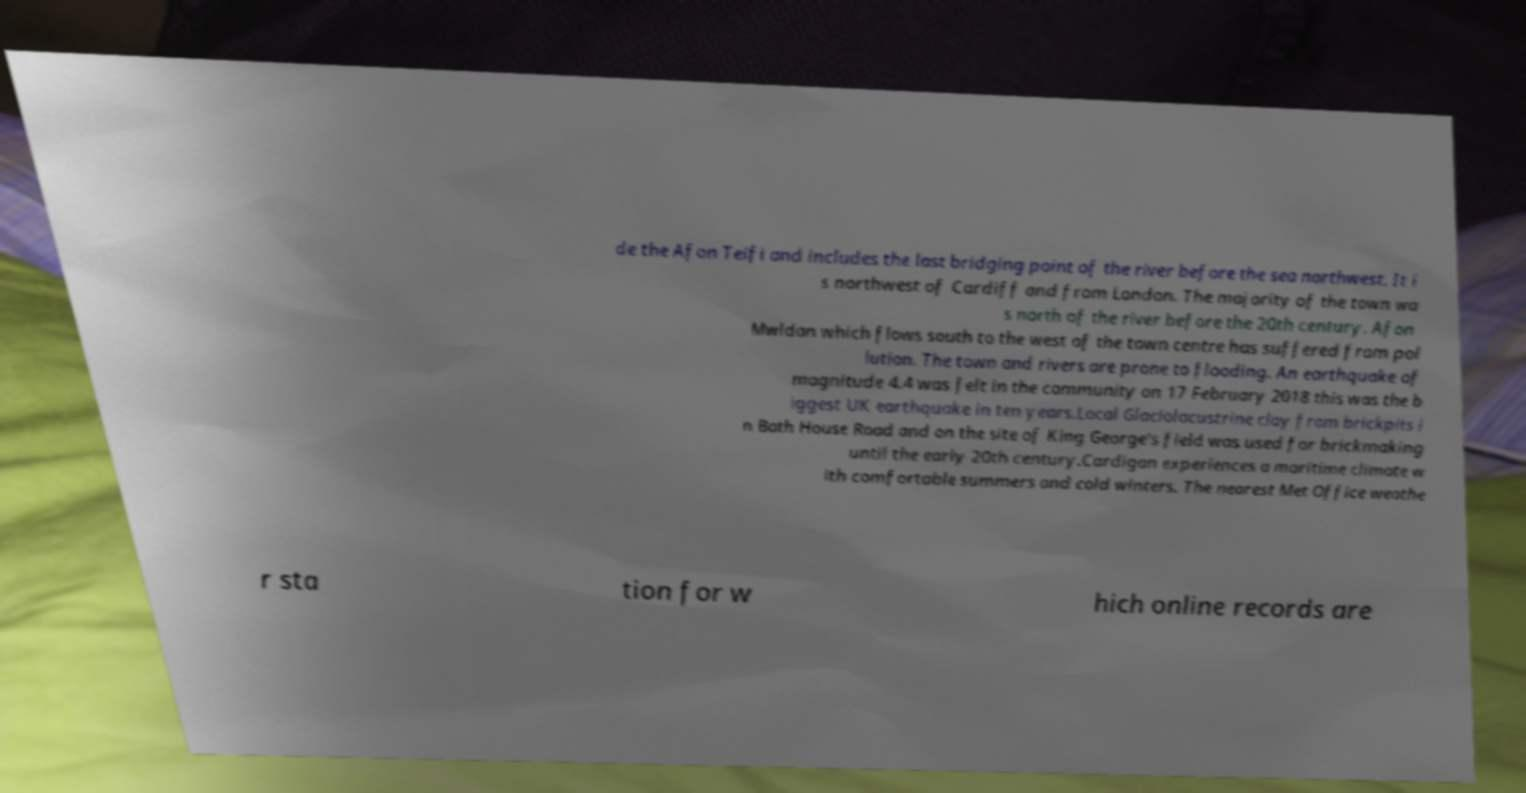Could you extract and type out the text from this image? de the Afon Teifi and includes the last bridging point of the river before the sea northwest. It i s northwest of Cardiff and from London. The majority of the town wa s north of the river before the 20th century. Afon Mwldan which flows south to the west of the town centre has suffered from pol lution. The town and rivers are prone to flooding. An earthquake of magnitude 4.4 was felt in the community on 17 February 2018 this was the b iggest UK earthquake in ten years.Local Glaciolacustrine clay from brickpits i n Bath House Road and on the site of King George's field was used for brickmaking until the early 20th century.Cardigan experiences a maritime climate w ith comfortable summers and cold winters. The nearest Met Office weathe r sta tion for w hich online records are 